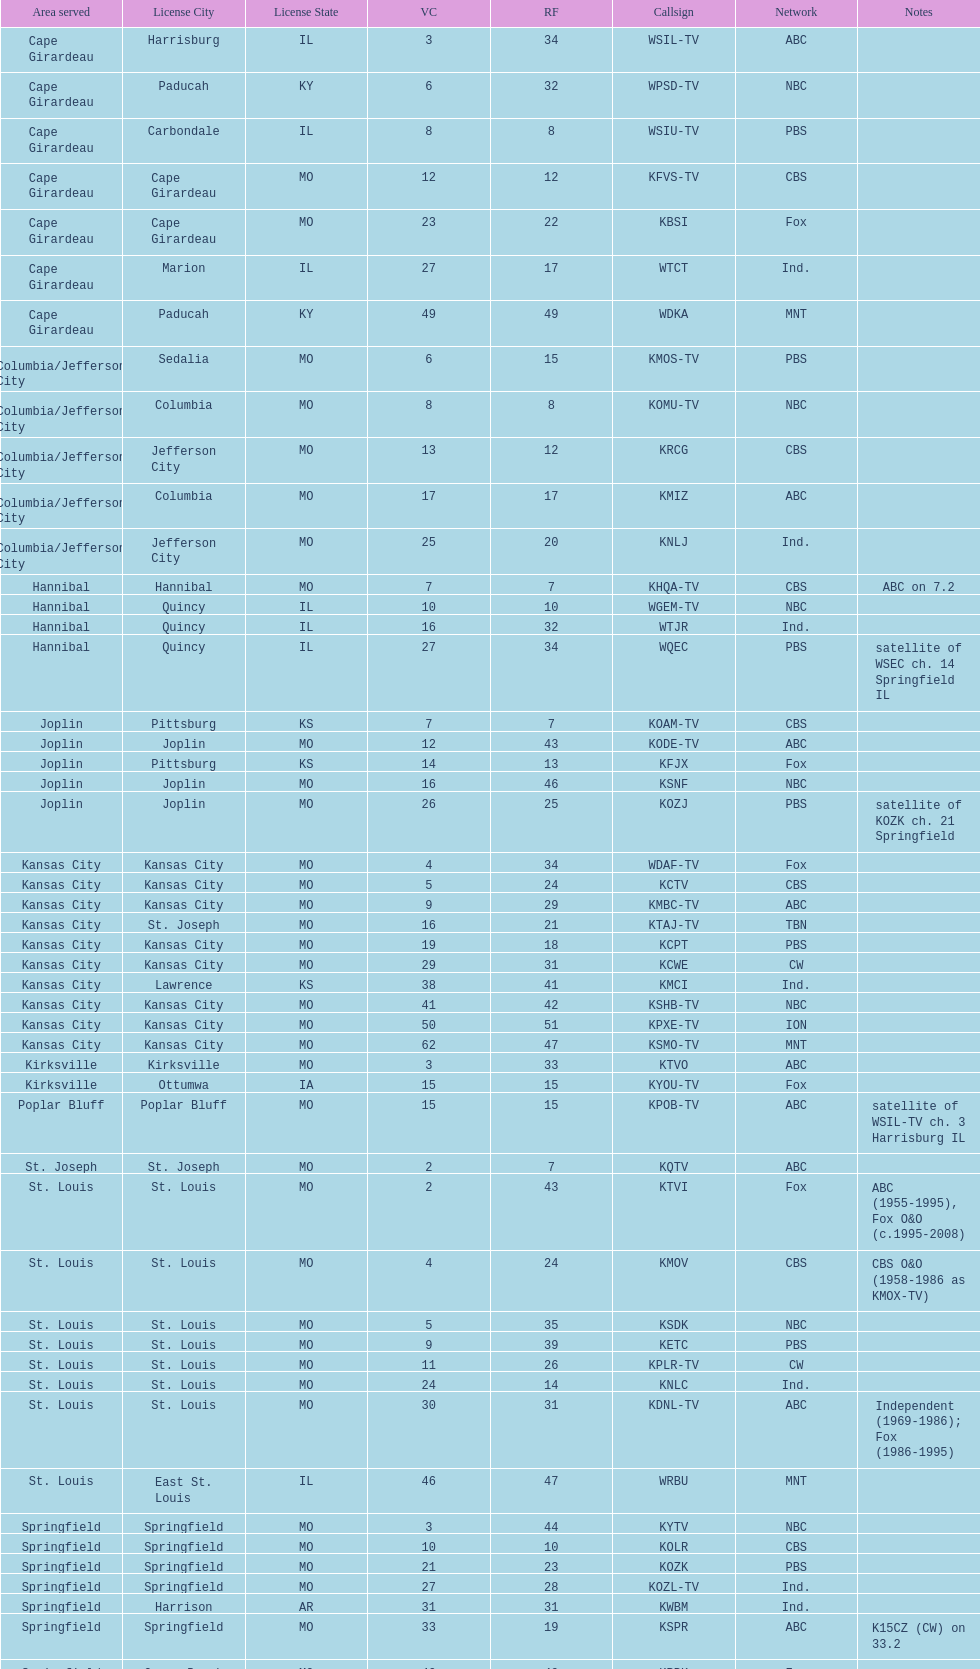What is the total number of cbs stations? 7. 